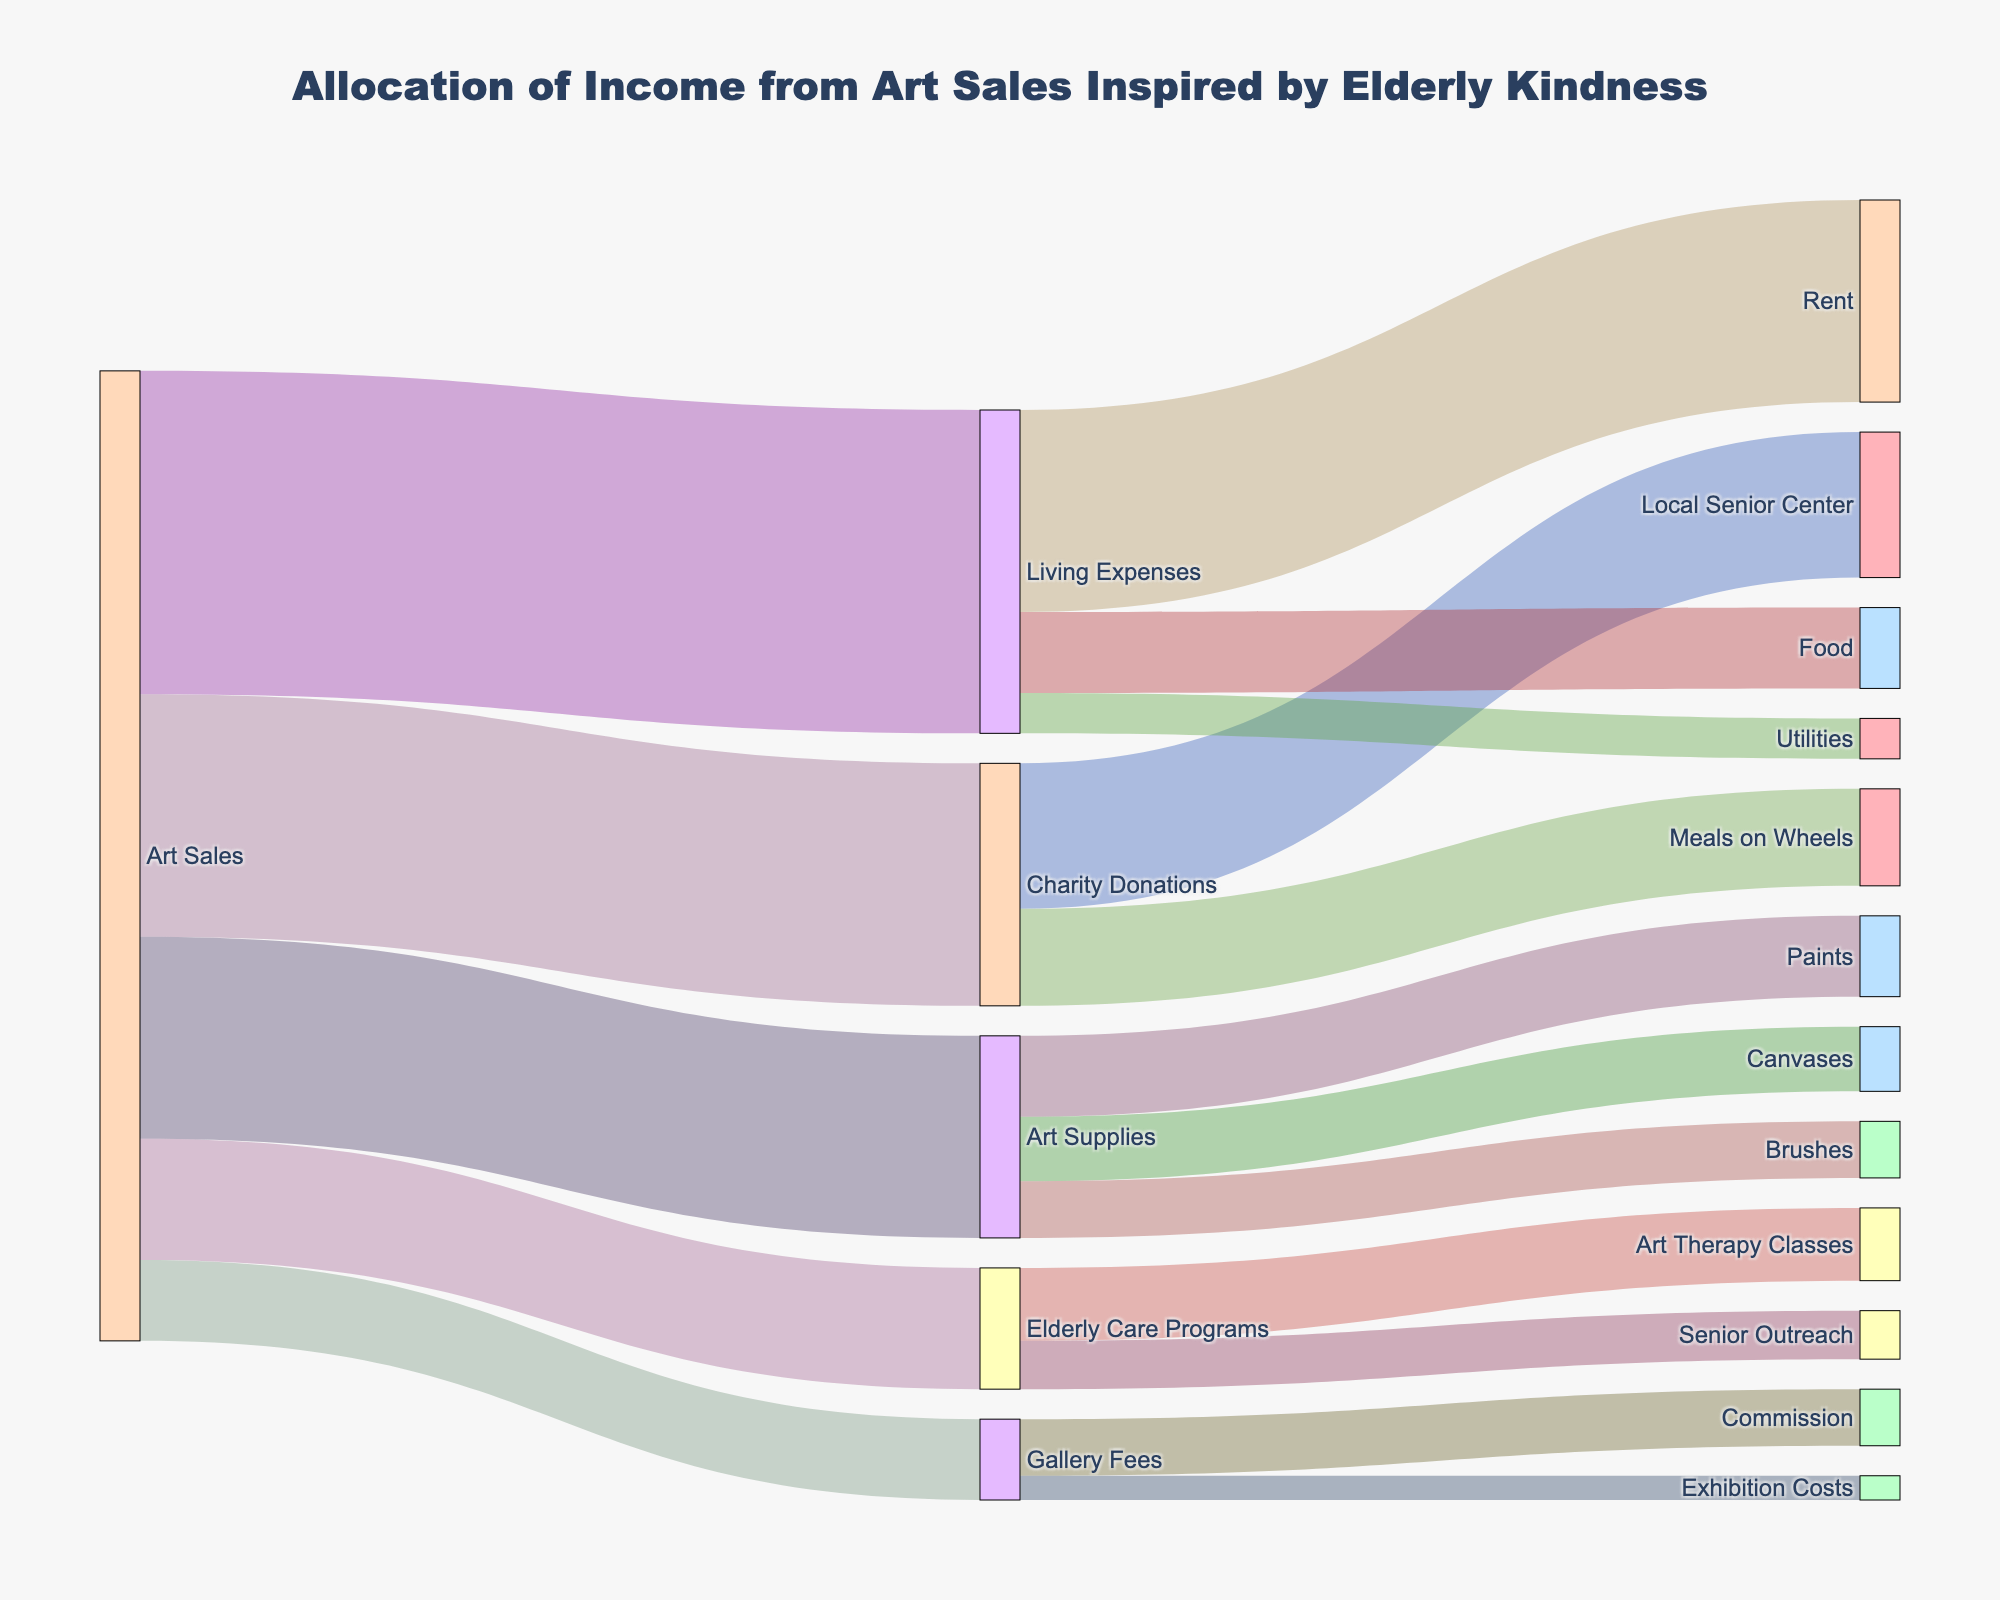What is the title of the Sankey diagram? The title is located at the top center of the Sankey diagram. It provides an overview of what the diagram represents.
Answer: Allocation of Income from Art Sales Inspired by Elderly Kindness Which category receives the highest distribution from Art Sales? By looking at the links originating from "Art Sales", the width of the links indicates the amount allocated. The link to "Living Expenses" is the widest.
Answer: Living Expenses How much is allocated to Art Supplies? The Sankey diagram shows the amount of each allocation right next to the links. The link from "Art Sales" to "Art Supplies" shows the value.
Answer: 2500 How much income goes to Elderly Care Programs from Art Sales? This can be found by looking at the width of the link between "Art Sales" and "Elderly Care Programs" and the value tagged next to it on the diagram.
Answer: 1500 Comparing "Rent" and "Food" under Living Expenses, which one receives more funds? Look at the width of the links and the values associated with "Rent" and "Food". "Rent" has a higher value than "Food".
Answer: Rent How much money is spent on brushes for Art Supplies? Observe the link from "Art Supplies" to "Brushes" to find its value.
Answer: 700 Which Elderly Care Program receives the most funding, Art Therapy Classes or Senior Outreach? The values are located next to the links from "Elderly Care Programs" to both "Art Therapy Classes" and "Senior Outreach". "Art Therapy Classes" receive more.
Answer: Art Therapy Classes What percentage of 'Art Sales' is allocated for 'Living Expenses'? Divide the value for "Living Expenses" by the total "Art Sales" income, then multiply by 100 to get the percentage. Calculation: (4000/12000) * 100%.
Answer: 33.33% 